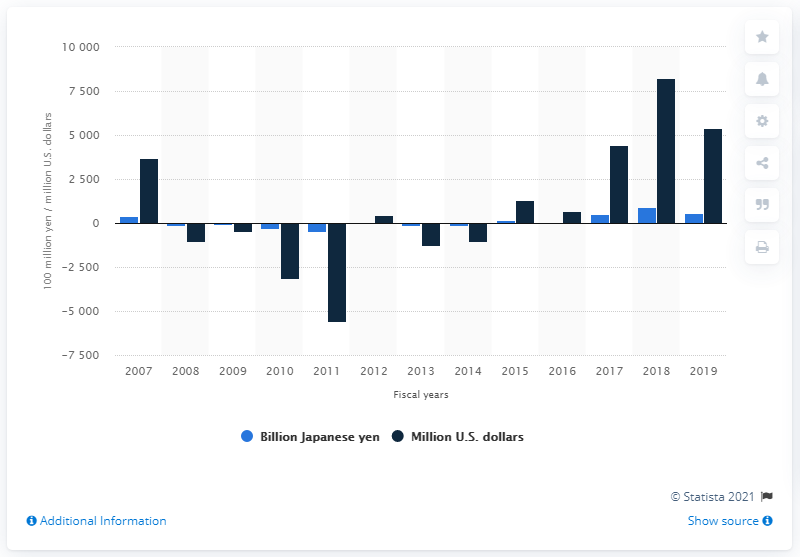Identify some key points in this picture. Sony employs approximately 54,200 workers. Sony reported a net income of 44,260 million yen in the previous financial year. The expected annual expenditure on consumer electronics was projected to exceed $5,420 in 2018. Sony reported a net income of 54,200 million Japanese yen in the 2019 financial year. 